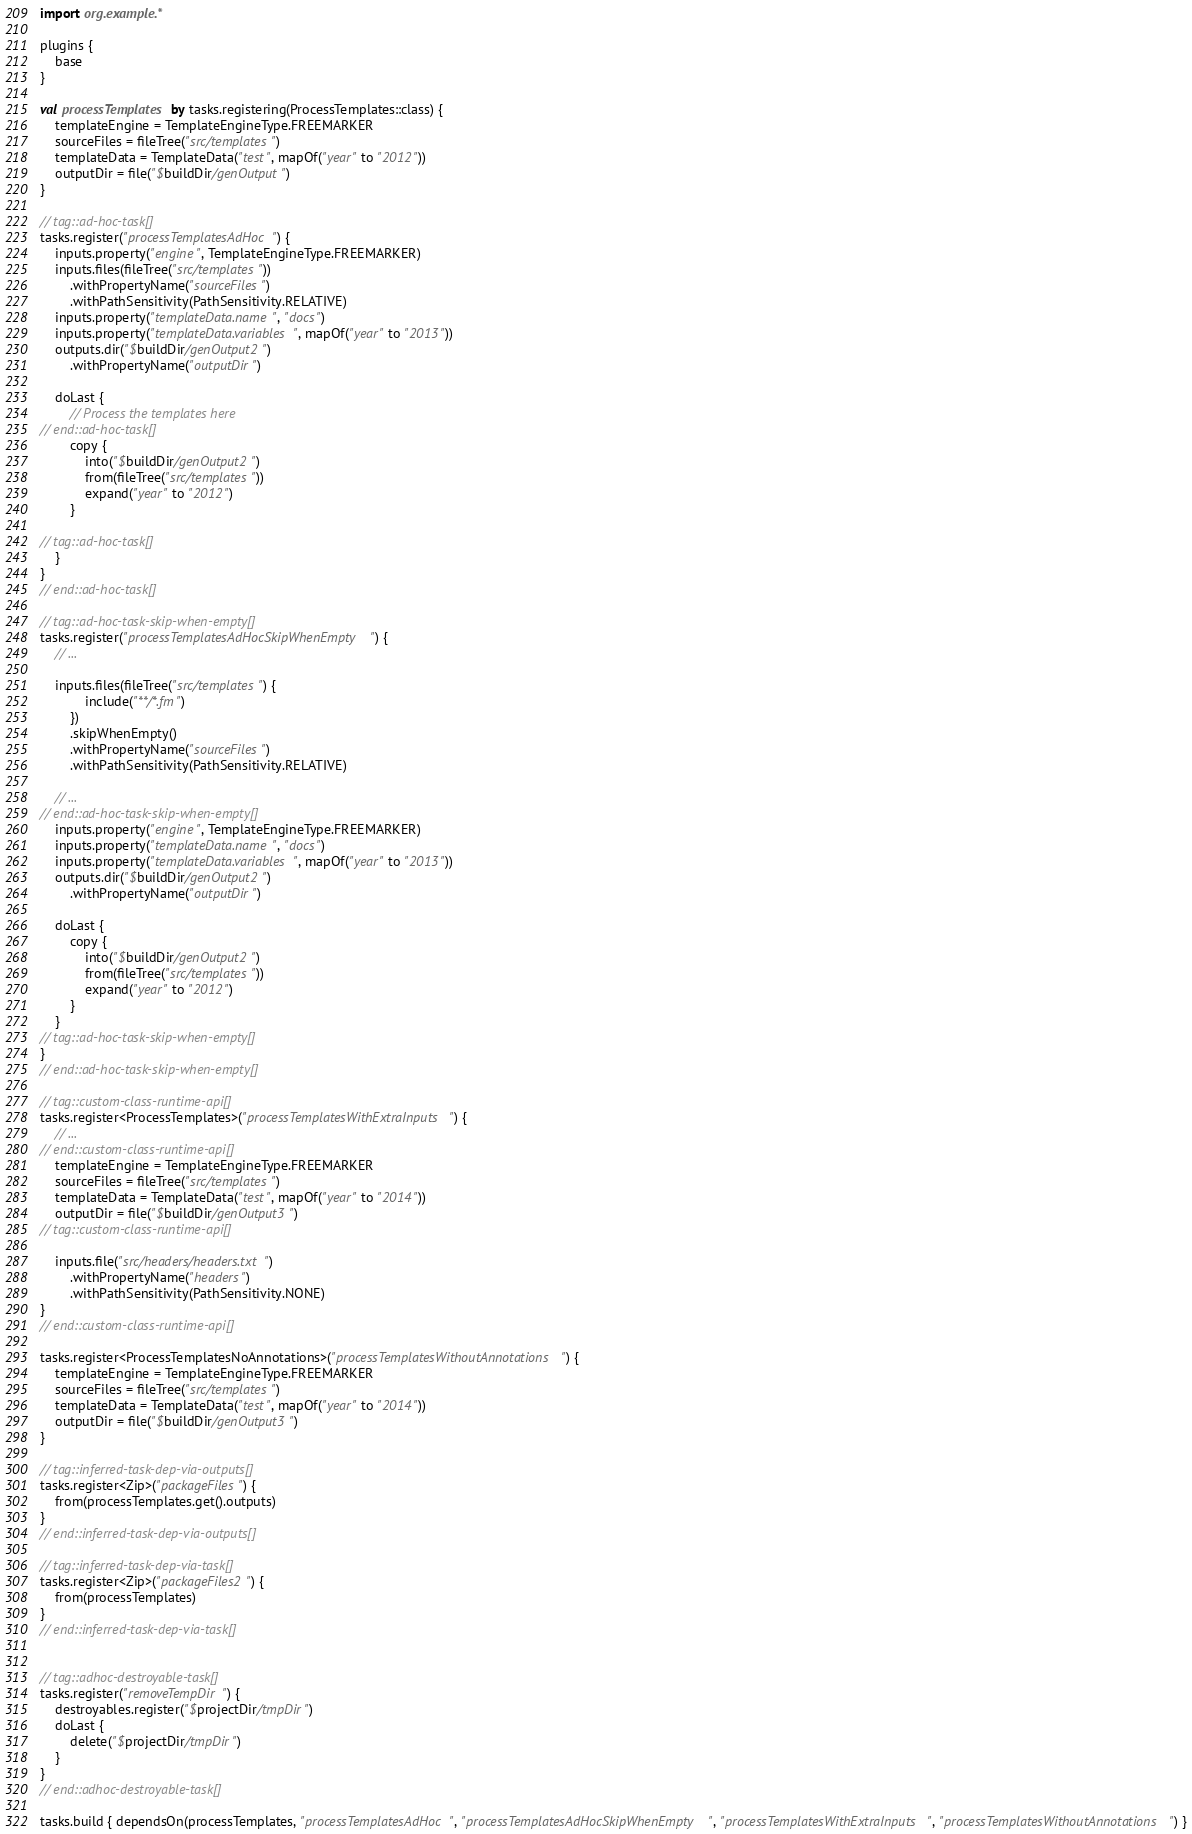<code> <loc_0><loc_0><loc_500><loc_500><_Kotlin_>import org.example.*

plugins {
    base
}

val processTemplates by tasks.registering(ProcessTemplates::class) {
    templateEngine = TemplateEngineType.FREEMARKER
    sourceFiles = fileTree("src/templates")
    templateData = TemplateData("test", mapOf("year" to "2012"))
    outputDir = file("$buildDir/genOutput")
}

// tag::ad-hoc-task[]
tasks.register("processTemplatesAdHoc") {
    inputs.property("engine", TemplateEngineType.FREEMARKER)
    inputs.files(fileTree("src/templates"))
        .withPropertyName("sourceFiles")
        .withPathSensitivity(PathSensitivity.RELATIVE)
    inputs.property("templateData.name", "docs")
    inputs.property("templateData.variables", mapOf("year" to "2013"))
    outputs.dir("$buildDir/genOutput2")
        .withPropertyName("outputDir")

    doLast {
        // Process the templates here
// end::ad-hoc-task[]
        copy {
            into("$buildDir/genOutput2")
            from(fileTree("src/templates"))
            expand("year" to "2012")
        }

// tag::ad-hoc-task[]
    }
}
// end::ad-hoc-task[]

// tag::ad-hoc-task-skip-when-empty[]
tasks.register("processTemplatesAdHocSkipWhenEmpty") {
    // ...

    inputs.files(fileTree("src/templates") {
            include("**/*.fm")
        })
        .skipWhenEmpty()
        .withPropertyName("sourceFiles")
        .withPathSensitivity(PathSensitivity.RELATIVE)

    // ...
// end::ad-hoc-task-skip-when-empty[]
    inputs.property("engine", TemplateEngineType.FREEMARKER)
    inputs.property("templateData.name", "docs")
    inputs.property("templateData.variables", mapOf("year" to "2013"))
    outputs.dir("$buildDir/genOutput2")
        .withPropertyName("outputDir")

    doLast {
        copy {
            into("$buildDir/genOutput2")
            from(fileTree("src/templates"))
            expand("year" to "2012")
        }
    }
// tag::ad-hoc-task-skip-when-empty[]
}
// end::ad-hoc-task-skip-when-empty[]

// tag::custom-class-runtime-api[]
tasks.register<ProcessTemplates>("processTemplatesWithExtraInputs") {
    // ...
// end::custom-class-runtime-api[]
    templateEngine = TemplateEngineType.FREEMARKER
    sourceFiles = fileTree("src/templates")
    templateData = TemplateData("test", mapOf("year" to "2014"))
    outputDir = file("$buildDir/genOutput3")
// tag::custom-class-runtime-api[]

    inputs.file("src/headers/headers.txt")
        .withPropertyName("headers")
        .withPathSensitivity(PathSensitivity.NONE)
}
// end::custom-class-runtime-api[]

tasks.register<ProcessTemplatesNoAnnotations>("processTemplatesWithoutAnnotations") {
    templateEngine = TemplateEngineType.FREEMARKER
    sourceFiles = fileTree("src/templates")
    templateData = TemplateData("test", mapOf("year" to "2014"))
    outputDir = file("$buildDir/genOutput3")
}

// tag::inferred-task-dep-via-outputs[]
tasks.register<Zip>("packageFiles") {
    from(processTemplates.get().outputs)
}
// end::inferred-task-dep-via-outputs[]

// tag::inferred-task-dep-via-task[]
tasks.register<Zip>("packageFiles2") {
    from(processTemplates)
}
// end::inferred-task-dep-via-task[]


// tag::adhoc-destroyable-task[]
tasks.register("removeTempDir") {
    destroyables.register("$projectDir/tmpDir")
    doLast {
        delete("$projectDir/tmpDir")
    }
}
// end::adhoc-destroyable-task[]

tasks.build { dependsOn(processTemplates, "processTemplatesAdHoc", "processTemplatesAdHocSkipWhenEmpty", "processTemplatesWithExtraInputs", "processTemplatesWithoutAnnotations") }
</code> 